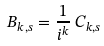Convert formula to latex. <formula><loc_0><loc_0><loc_500><loc_500>B _ { k , s } = \frac { 1 } { i ^ { k } } \, C _ { k , s }</formula> 